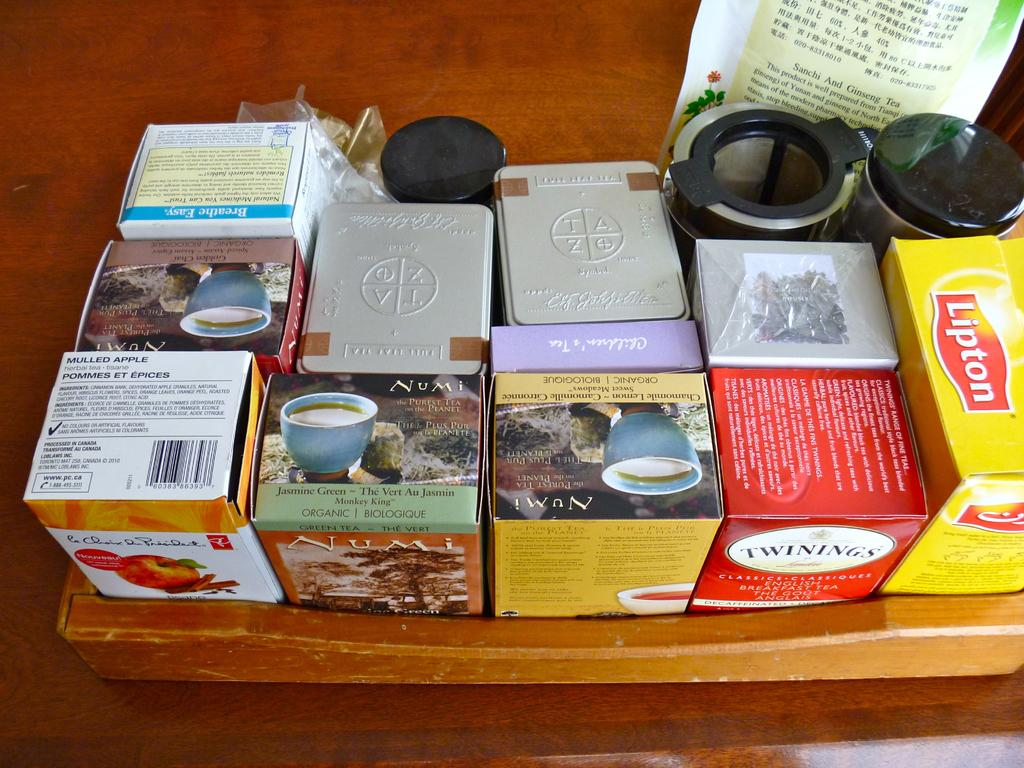Provide a one-sentence caption for the provided image. Various boxes of tea on a wooden table including Lipton, Numi and Twinings brands. 